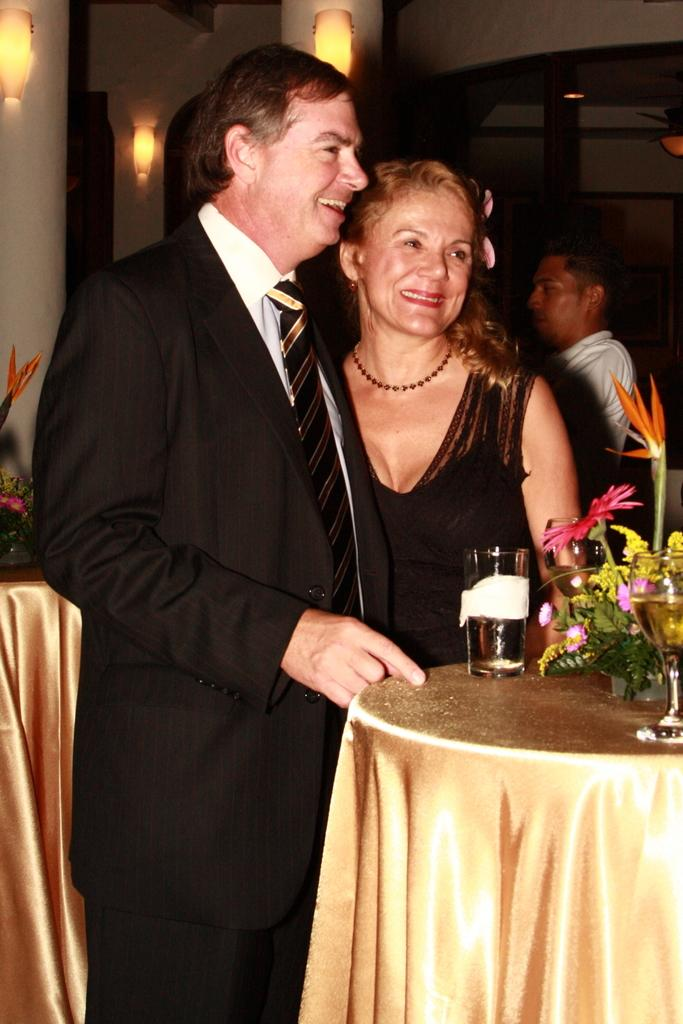How many people are present in the image? There are two people, a man and a woman, present in the image. What are the man and woman doing in the image? The man and woman are standing near a table. What objects can be seen on the table in the image? There are glasses and a flower vase on the table. Can you describe the background of the image? There is a person and lights visible in the background of the image. What is the position of the father in the image? There is no mention of a father in the image, so it is not possible to determine their position. 